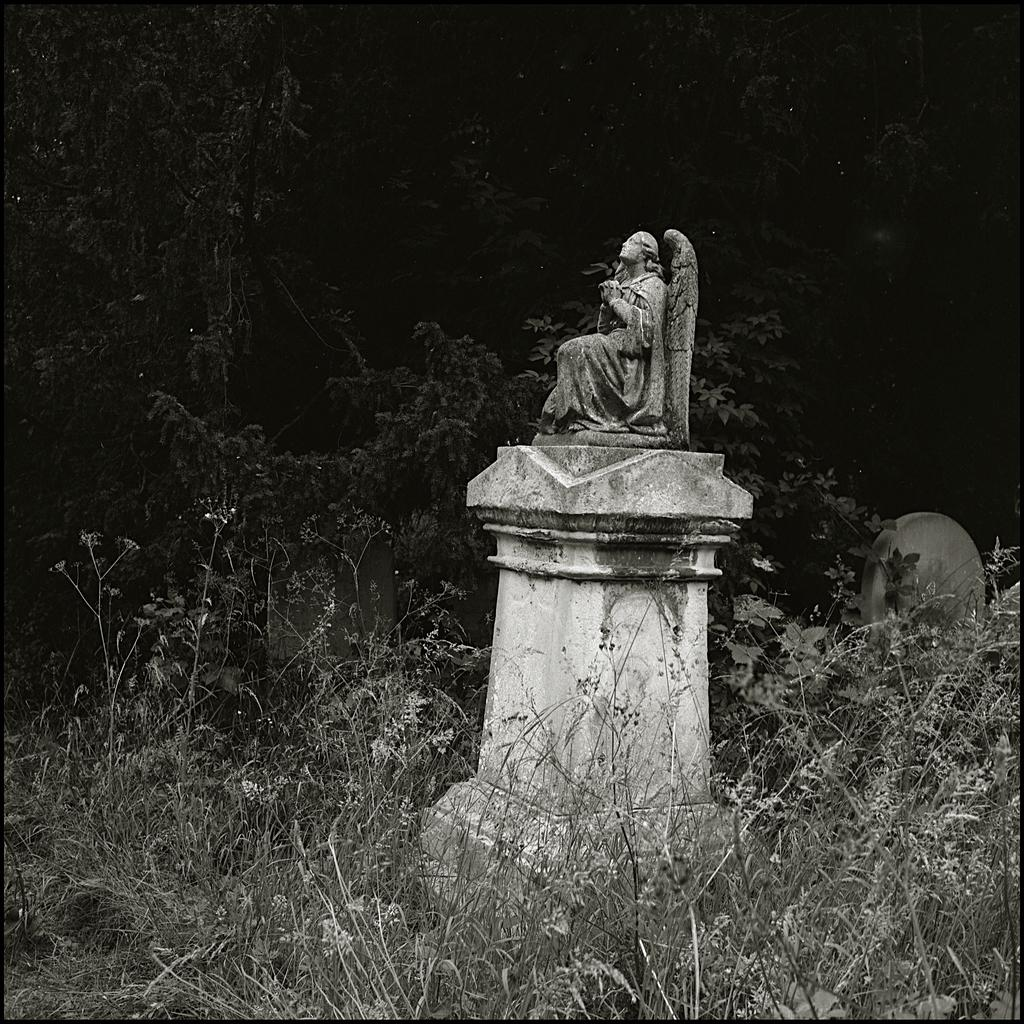What is the main subject in the picture? There is a statue in the picture. What type of vegetation can be seen in the picture? There are trees in the picture. What is the ground made of in the picture? There is grass in the picture. What type of lace can be seen on the statue in the picture? There is no lace present on the statue in the picture. 